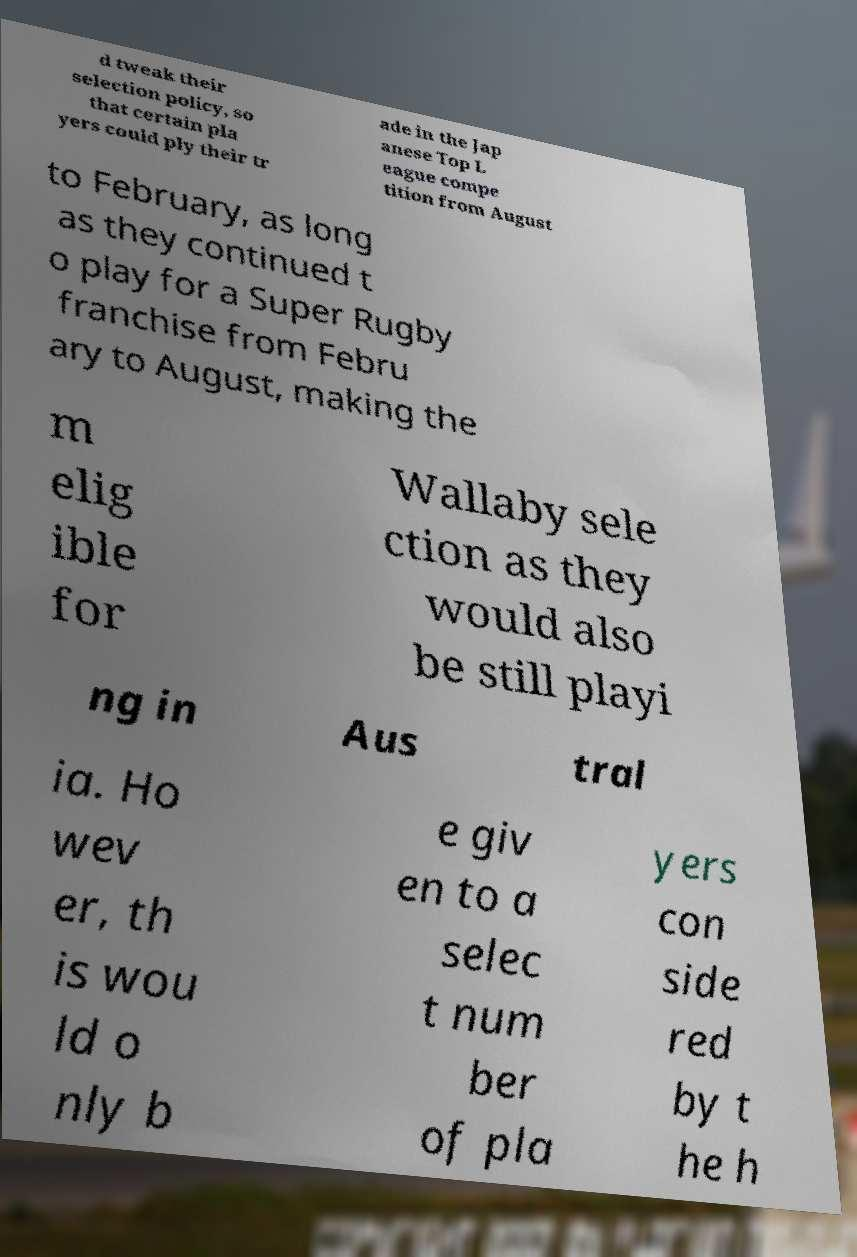Can you accurately transcribe the text from the provided image for me? d tweak their selection policy, so that certain pla yers could ply their tr ade in the Jap anese Top L eague compe tition from August to February, as long as they continued t o play for a Super Rugby franchise from Febru ary to August, making the m elig ible for Wallaby sele ction as they would also be still playi ng in Aus tral ia. Ho wev er, th is wou ld o nly b e giv en to a selec t num ber of pla yers con side red by t he h 